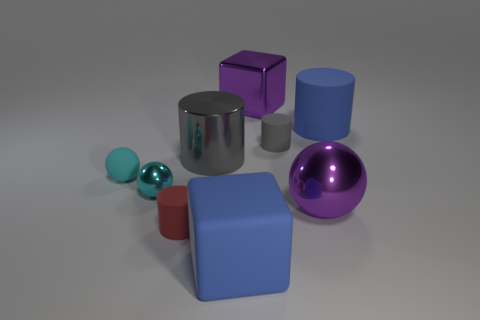Subtract all red rubber cylinders. How many cylinders are left? 3 Subtract all green cylinders. How many cyan spheres are left? 2 Add 1 big matte blocks. How many objects exist? 10 Subtract all red cylinders. How many cylinders are left? 3 Subtract 1 cylinders. How many cylinders are left? 3 Subtract all blocks. How many objects are left? 7 Add 9 small red objects. How many small red objects exist? 10 Subtract 0 cyan cubes. How many objects are left? 9 Subtract all blue spheres. Subtract all red blocks. How many spheres are left? 3 Subtract all big blue rubber cubes. Subtract all tiny balls. How many objects are left? 6 